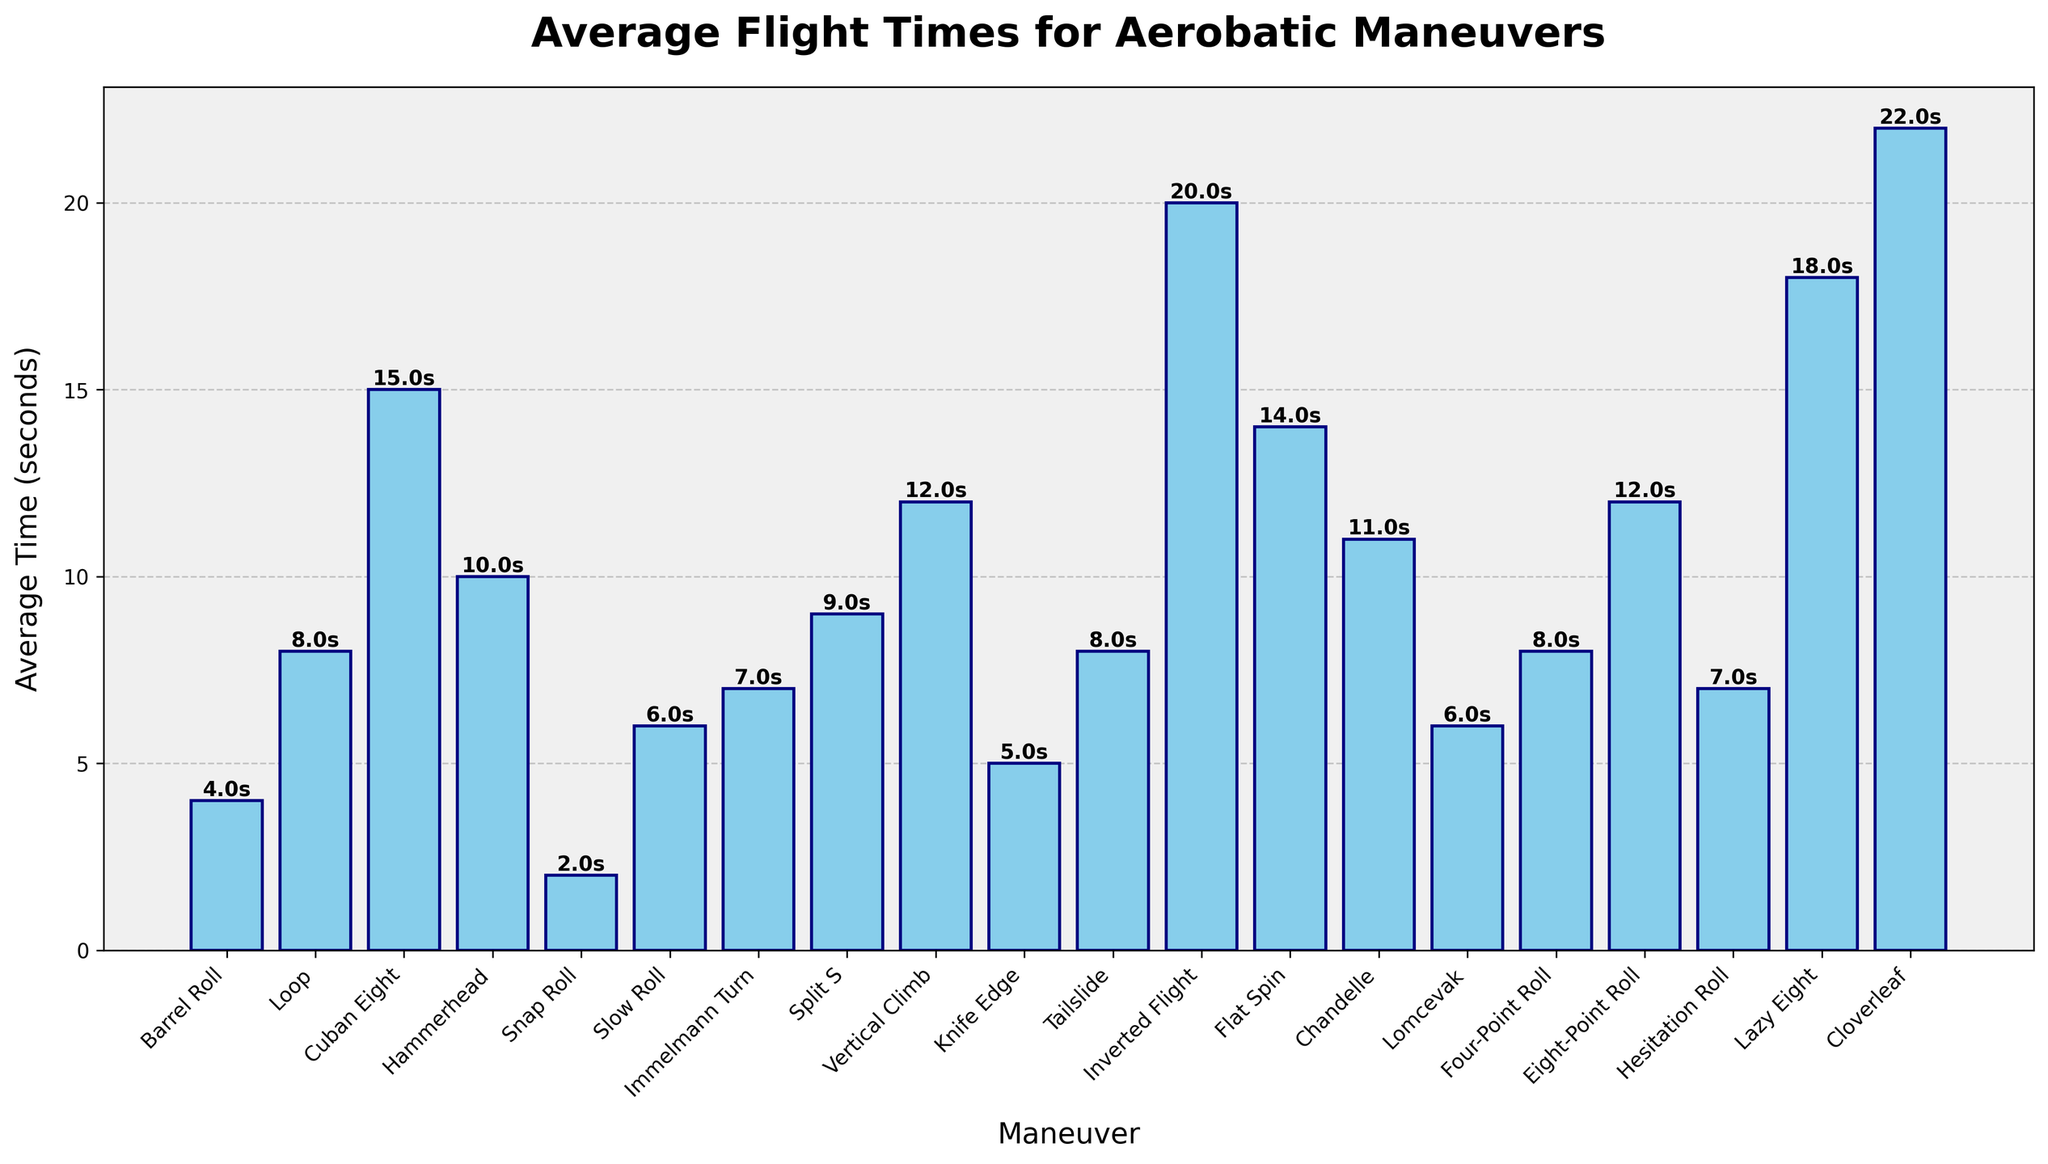Which maneuver has the longest average flight time? By visually assessing the height of the bars in the bar chart, the maneuver with the tallest bar represents the longest average flight time. The "Cloverleaf" maneuver has the longest average flight time, indicated by the highest bar reaching 22 seconds.
Answer: Cloverleaf Which maneuver takes less time: the Barrel Roll or the Slow Roll? By comparing the heights of the bars for "Barrel Roll" and "Slow Roll," the "Barrel Roll" bar is shorter. This indicates "Barrel Roll" has a shorter average flight time (4 seconds) compared to "Slow Roll" (6 seconds).
Answer: Barrel Roll What is the combined average flight time of the Loop and Lazy Eight maneuvers? To find this, we sum the average flight times of "Loop" (8 seconds) and "Lazy Eight" (18 seconds). Therefore, the combined time is 8 + 18 = 26 seconds.
Answer: 26 seconds Which maneuver is performed faster, the Hammerhead or the Split S? Comparing the heights of the bars for "Hammerhead" and "Split S," the bar for "Hammerhead" is shorter. This means "Hammerhead" has a shorter average flight time (10 seconds) compared to "Split S" (9 seconds).
Answer: Hammerhead How many maneuvers have an average flight time greater than 10 seconds? By counting the bars in the bar chart that are taller than the 10-second mark on the y-axis, the maneuvers are "Cuban Eight", "Inverted Flight", "Flat Spin", "Lazy Eight", "Cloverleaf", "Chandelle", and "Eight-Point Roll". There are 7 maneuvers.
Answer: 7 What is the difference in average flight time between the Slow Roll and the Knife Edge? The average flight time of "Slow Roll" is 6 seconds, and for "Knife Edge" it is 5 seconds. The difference is 6 - 5 = 1 second.
Answer: 1 second Which maneuver has an equal average flight time to the Four-Point Roll? By looking for bars with a height equal to that of "Four-Point Roll," which is 8 seconds, the maneuvers are "Loop", "Tailslide", and "Four-Point Roll".
Answer: Loop, Tailslide, Four-Point Roll What is the median average flight time among all the maneuvers? To find the median, list the average flight times in ascending order: 2, 4, 5, 6, 6, 7, 7, 8, 8, 8, 9, 10, 11, 12, 12, 14, 15, 18, 20, 22. The middle two values are 8 and 8 since there are 20 maneuvers. Therefore, the median is (8 + 8) / 2 = 8 seconds.
Answer: 8 seconds 